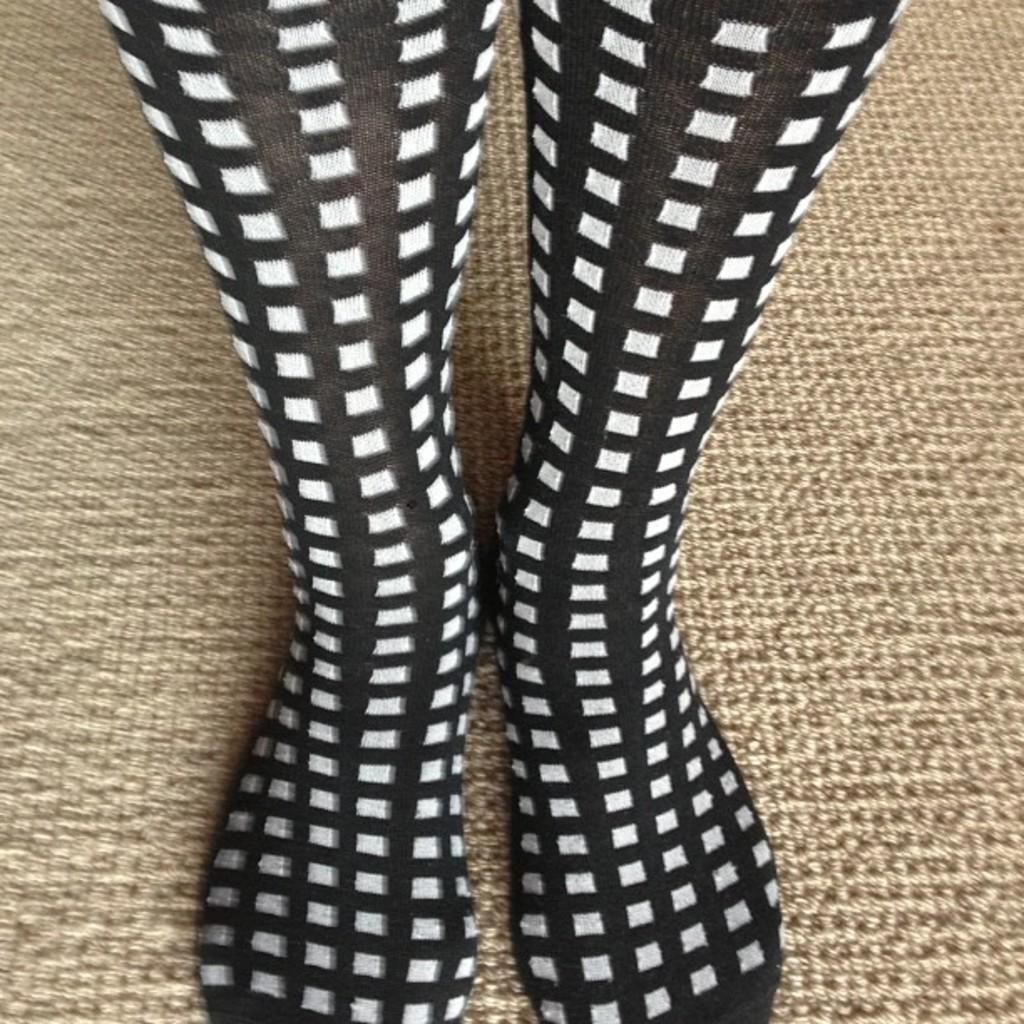What type of clothing item is in the image? There is a pair of socks in the image. What colors are the socks? The socks are black and white in color. What type of flooring is visible in the image? There is a carpet visible in the image. What type of skin condition can be seen on the socks in the image? There is no skin condition present on the socks in the image, as socks are not a living organism and do not have skin. 